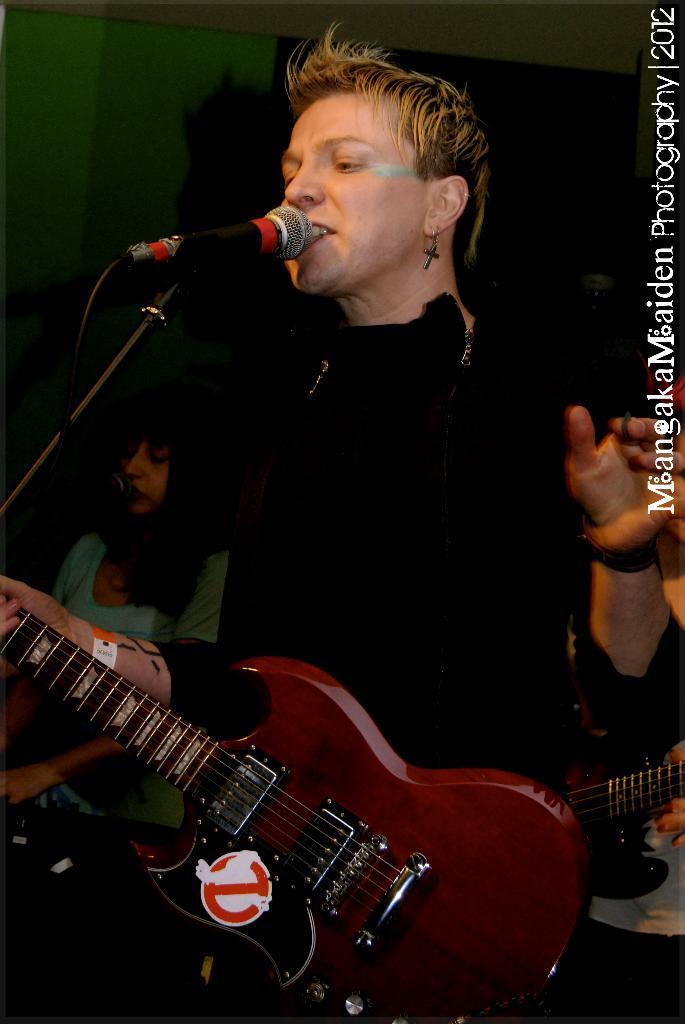In one or two sentences, can you explain what this image depicts? Here is a person standing and singing a song. This person is holding guitar. At the background I can see another person standing. This is the mike with the mike stand. 